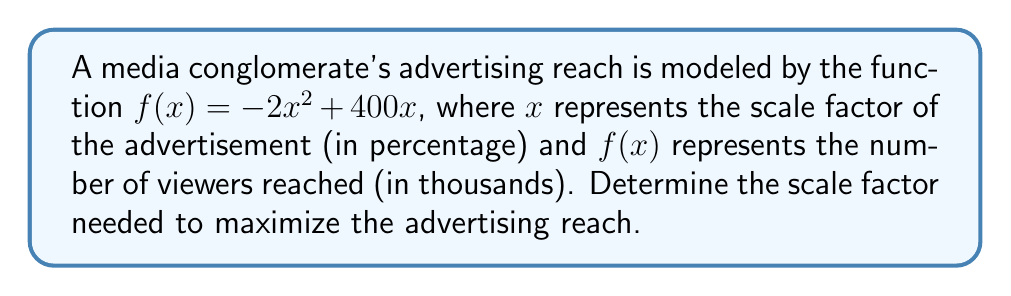What is the answer to this math problem? To find the scale factor that maximizes the advertising reach, we need to follow these steps:

1) The function $f(x) = -2x^2 + 400x$ is a quadratic function, which forms a parabola when graphed. The maximum point of this parabola will give us the maximum advertising reach.

2) To find the maximum point, we need to find the vertex of the parabola. For a quadratic function in the form $f(x) = ax^2 + bx + c$, the x-coordinate of the vertex is given by $x = -\frac{b}{2a}$.

3) In our function $f(x) = -2x^2 + 400x$, we have:
   $a = -2$
   $b = 400$
   $c = 0$

4) Applying the formula:
   $$x = -\frac{b}{2a} = -\frac{400}{2(-2)} = -\frac{400}{-4} = 100$$

5) This means that the scale factor that maximizes the advertising reach is 100%.

6) To verify, we can calculate the second derivative:
   $f'(x) = -4x + 400$
   $f''(x) = -4$

   Since $f''(x)$ is negative, this confirms that x = 100 gives a maximum, not a minimum.

7) We can also calculate the maximum reach by plugging x = 100 into the original function:
   $f(100) = -2(100)^2 + 400(100) = -20,000 + 40,000 = 20,000$

   This means the maximum reach is 20,000,000 viewers.
Answer: The scale factor needed to maximize the advertising reach is 100%. 